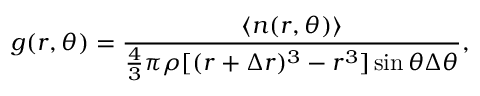<formula> <loc_0><loc_0><loc_500><loc_500>g ( r , \theta ) = \frac { \langle n ( r , \theta ) \rangle } { \frac { 4 } { 3 } \pi \rho [ ( r + \Delta r ) ^ { 3 } - r ^ { 3 } ] \sin \theta \Delta \theta } ,</formula> 